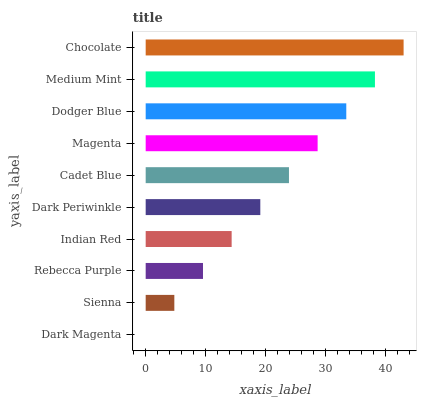Is Dark Magenta the minimum?
Answer yes or no. Yes. Is Chocolate the maximum?
Answer yes or no. Yes. Is Sienna the minimum?
Answer yes or no. No. Is Sienna the maximum?
Answer yes or no. No. Is Sienna greater than Dark Magenta?
Answer yes or no. Yes. Is Dark Magenta less than Sienna?
Answer yes or no. Yes. Is Dark Magenta greater than Sienna?
Answer yes or no. No. Is Sienna less than Dark Magenta?
Answer yes or no. No. Is Cadet Blue the high median?
Answer yes or no. Yes. Is Dark Periwinkle the low median?
Answer yes or no. Yes. Is Medium Mint the high median?
Answer yes or no. No. Is Medium Mint the low median?
Answer yes or no. No. 